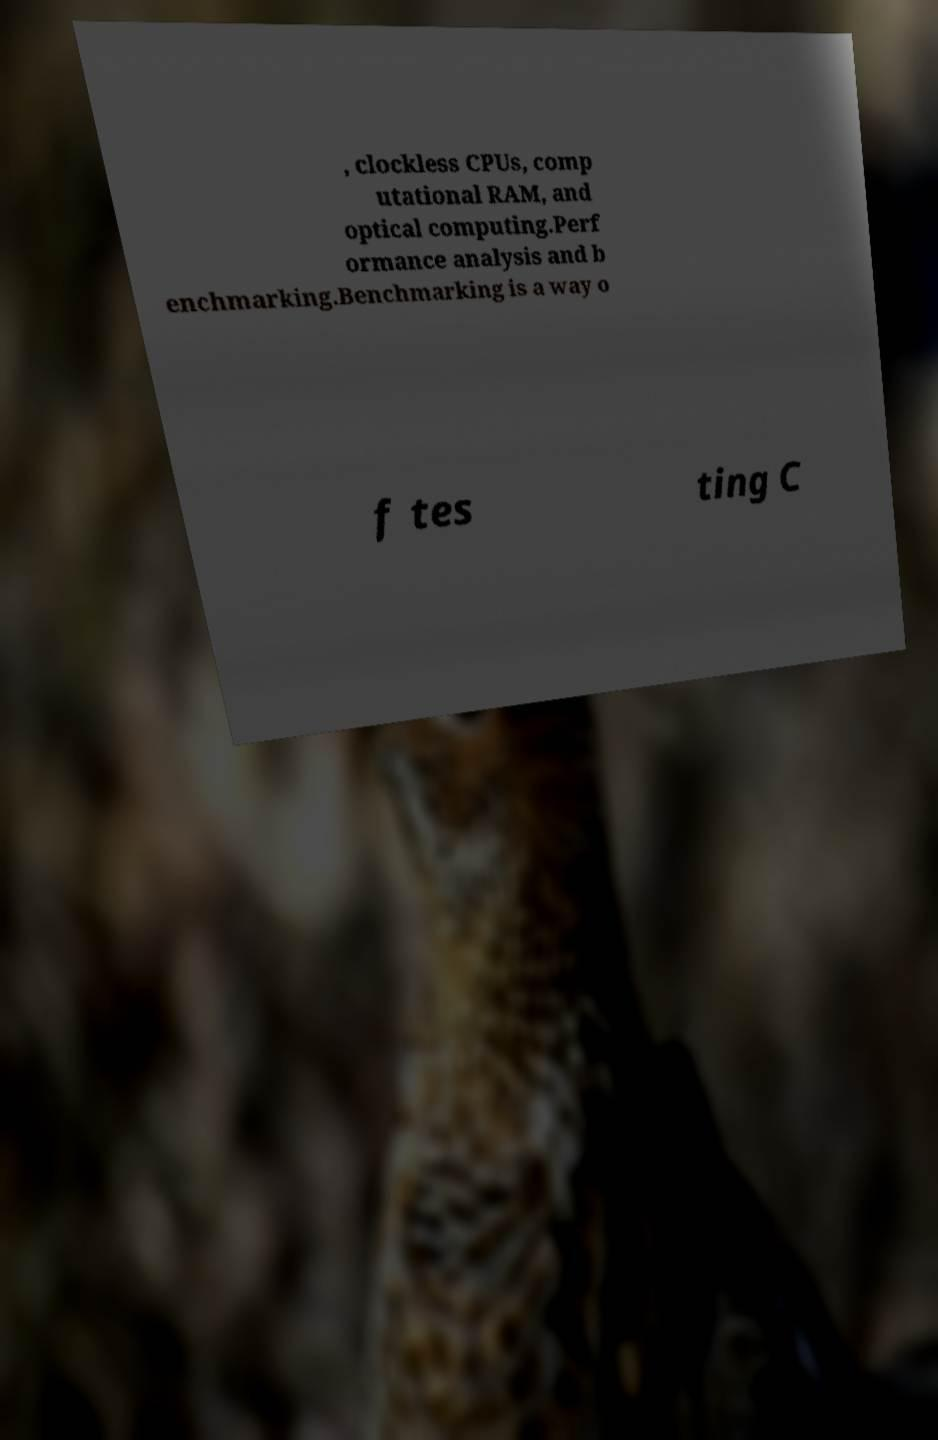Could you extract and type out the text from this image? , clockless CPUs, comp utational RAM, and optical computing.Perf ormance analysis and b enchmarking.Benchmarking is a way o f tes ting C 